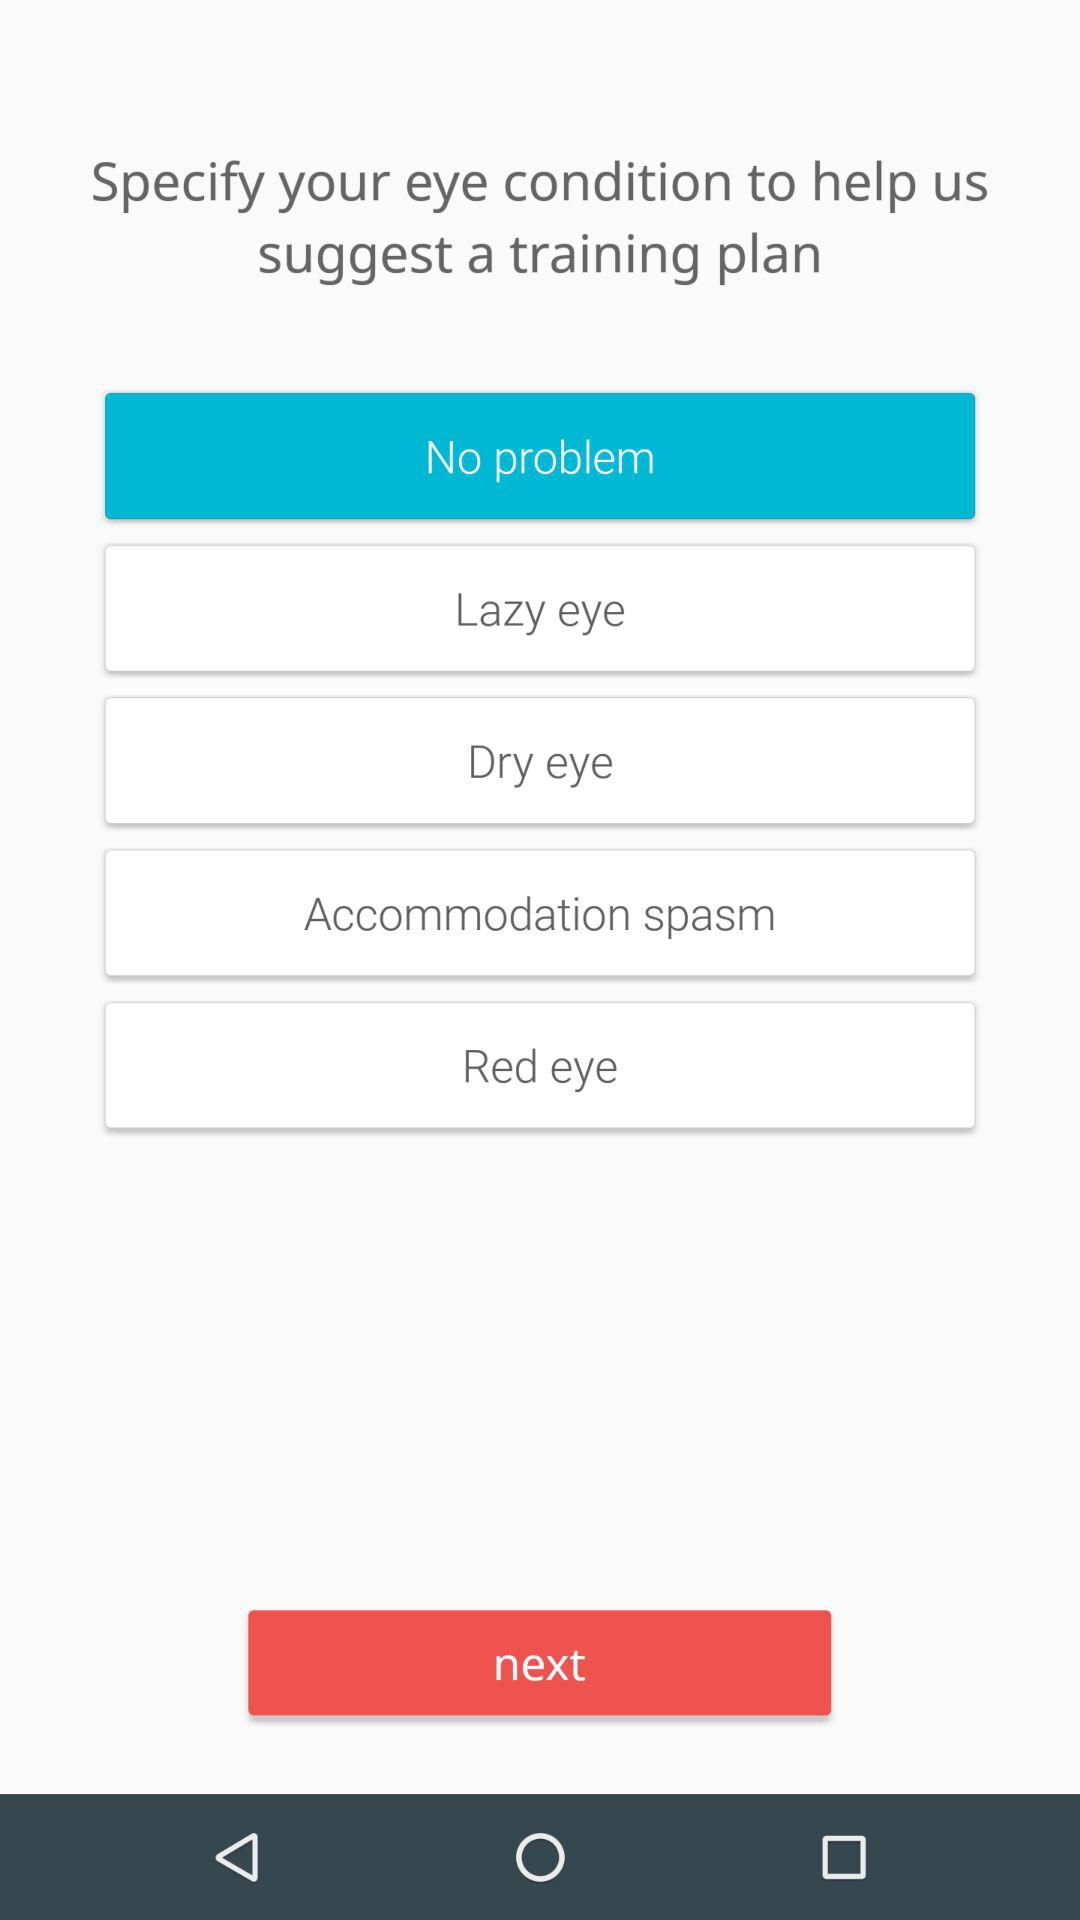How many training plans does the app suggest?
Answer the question using a single word or phrase. 5 